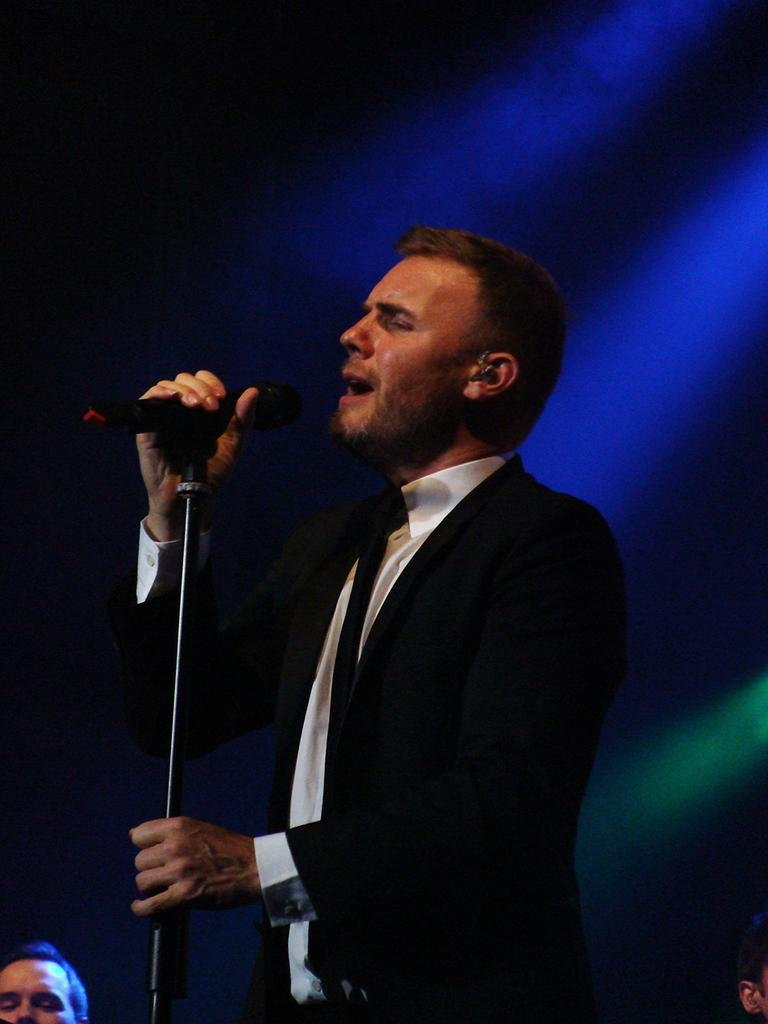Who is the main subject in the picture? There is a man in the picture. What is the man doing in the image? The man is standing and singing. What object is the man holding in his hand? The man is holding a microphone in his hand. What type of advertisement can be seen on the wall behind the man? There is no advertisement visible in the image; it only shows a man standing and singing while holding a microphone. 